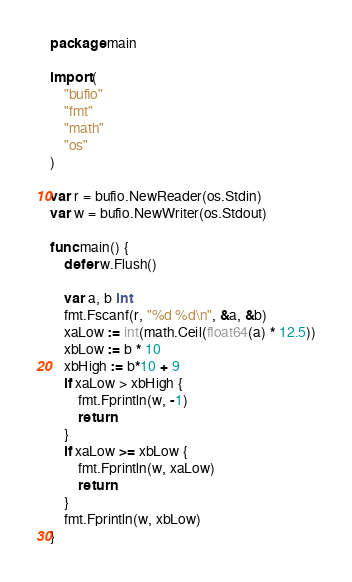<code> <loc_0><loc_0><loc_500><loc_500><_Go_>package main

import (
	"bufio"
	"fmt"
	"math"
	"os"
)

var r = bufio.NewReader(os.Stdin)
var w = bufio.NewWriter(os.Stdout)

func main() {
	defer w.Flush()

	var a, b int
	fmt.Fscanf(r, "%d %d\n", &a, &b)
	xaLow := int(math.Ceil(float64(a) * 12.5))
	xbLow := b * 10
	xbHigh := b*10 + 9
	if xaLow > xbHigh {
		fmt.Fprintln(w, -1)
		return
	}
	if xaLow >= xbLow {
		fmt.Fprintln(w, xaLow)
		return
	}
	fmt.Fprintln(w, xbLow)
}
</code> 